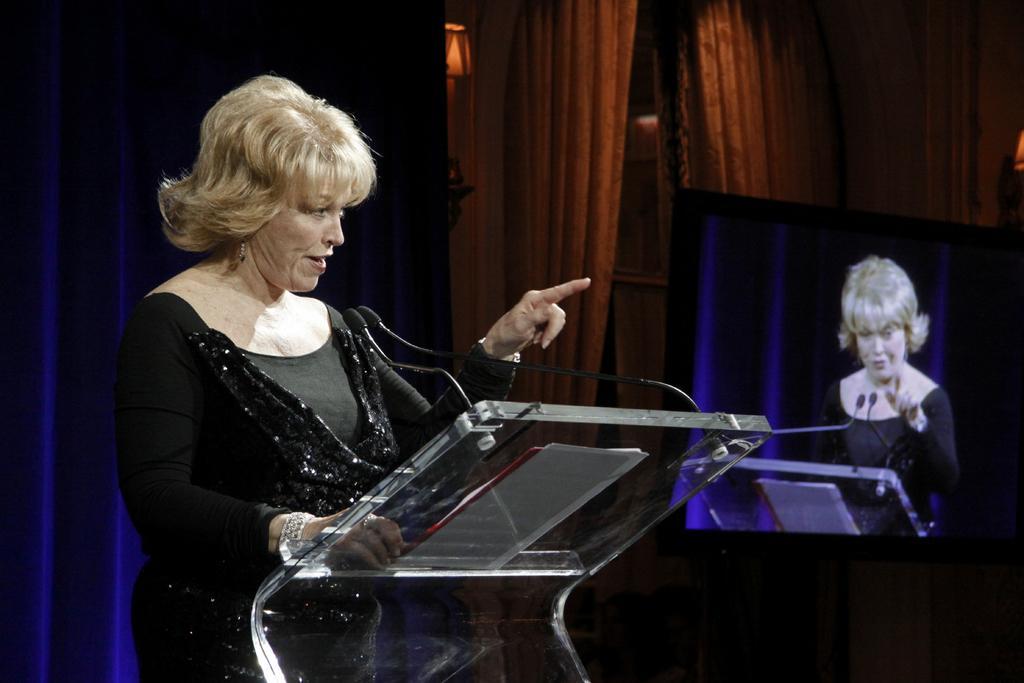Could you give a brief overview of what you see in this image? The woman wearing black dress is standing and speaking in front of a mic and there is a television which shows a picture on it in the right corner. 